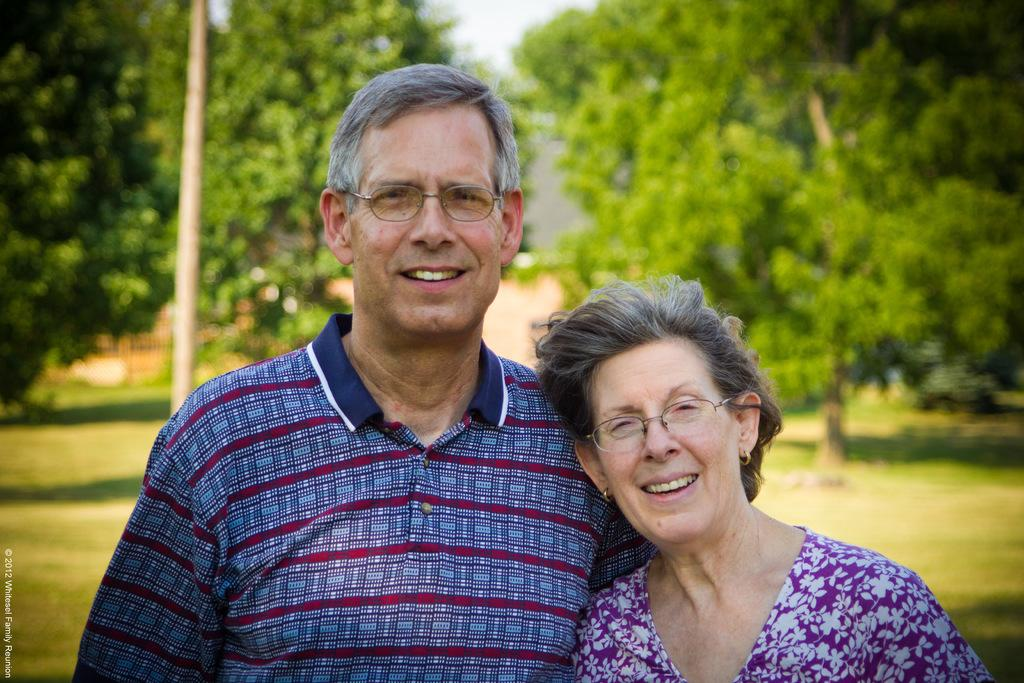How many people are in the image? There are two people standing in the image. What is located behind the people? There is a pole behind the people. What can be seen in the background of the image? Trees and the sky are visible in the background. Is there any additional information about the image? Yes, there is a watermark on the image. What type of cast can be seen on the crow's wing in the image? There is no crow or cast present in the image. How does the watermark move around in the image? The watermark does not move around in the image; it is a static element on the photograph. 